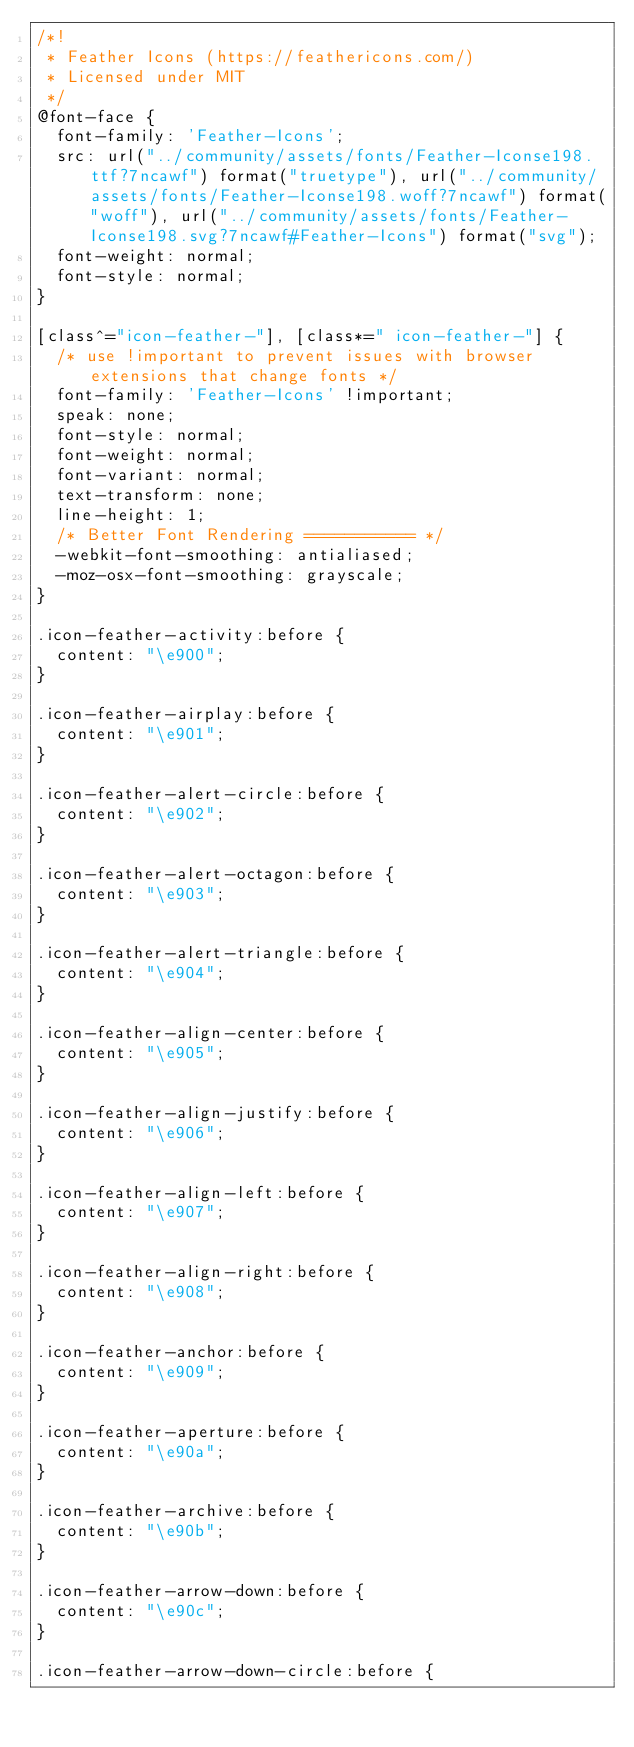<code> <loc_0><loc_0><loc_500><loc_500><_CSS_>/*!
 * Feather Icons (https://feathericons.com/)
 * Licensed under MIT
 */
@font-face {
  font-family: 'Feather-Icons';
  src: url("../community/assets/fonts/Feather-Iconse198.ttf?7ncawf") format("truetype"), url("../community/assets/fonts/Feather-Iconse198.woff?7ncawf") format("woff"), url("../community/assets/fonts/Feather-Iconse198.svg?7ncawf#Feather-Icons") format("svg");
  font-weight: normal;
  font-style: normal;
}

[class^="icon-feather-"], [class*=" icon-feather-"] {
  /* use !important to prevent issues with browser extensions that change fonts */
  font-family: 'Feather-Icons' !important;
  speak: none;
  font-style: normal;
  font-weight: normal;
  font-variant: normal;
  text-transform: none;
  line-height: 1;
  /* Better Font Rendering =========== */
  -webkit-font-smoothing: antialiased;
  -moz-osx-font-smoothing: grayscale;
}

.icon-feather-activity:before {
  content: "\e900";
}

.icon-feather-airplay:before {
  content: "\e901";
}

.icon-feather-alert-circle:before {
  content: "\e902";
}

.icon-feather-alert-octagon:before {
  content: "\e903";
}

.icon-feather-alert-triangle:before {
  content: "\e904";
}

.icon-feather-align-center:before {
  content: "\e905";
}

.icon-feather-align-justify:before {
  content: "\e906";
}

.icon-feather-align-left:before {
  content: "\e907";
}

.icon-feather-align-right:before {
  content: "\e908";
}

.icon-feather-anchor:before {
  content: "\e909";
}

.icon-feather-aperture:before {
  content: "\e90a";
}

.icon-feather-archive:before {
  content: "\e90b";
}

.icon-feather-arrow-down:before {
  content: "\e90c";
}

.icon-feather-arrow-down-circle:before {</code> 